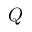<formula> <loc_0><loc_0><loc_500><loc_500>Q</formula> 